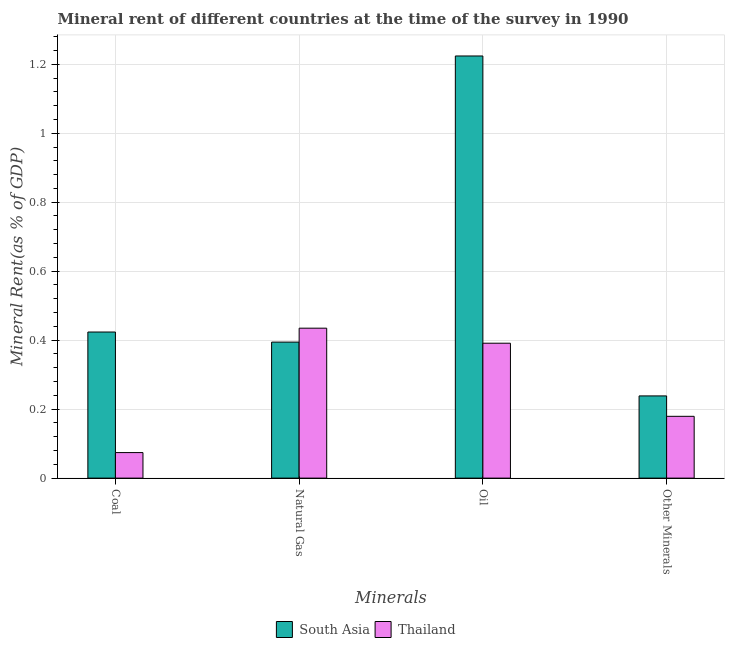How many different coloured bars are there?
Provide a short and direct response. 2. How many groups of bars are there?
Ensure brevity in your answer.  4. Are the number of bars per tick equal to the number of legend labels?
Keep it short and to the point. Yes. How many bars are there on the 1st tick from the left?
Offer a very short reply. 2. What is the label of the 1st group of bars from the left?
Keep it short and to the point. Coal. What is the  rent of other minerals in Thailand?
Offer a very short reply. 0.18. Across all countries, what is the maximum coal rent?
Make the answer very short. 0.42. Across all countries, what is the minimum oil rent?
Your response must be concise. 0.39. In which country was the natural gas rent minimum?
Provide a short and direct response. South Asia. What is the total natural gas rent in the graph?
Provide a short and direct response. 0.83. What is the difference between the coal rent in South Asia and that in Thailand?
Your response must be concise. 0.35. What is the difference between the  rent of other minerals in South Asia and the oil rent in Thailand?
Your answer should be very brief. -0.15. What is the average coal rent per country?
Offer a very short reply. 0.25. What is the difference between the  rent of other minerals and oil rent in Thailand?
Your response must be concise. -0.21. In how many countries, is the oil rent greater than 0.6400000000000001 %?
Provide a succinct answer. 1. What is the ratio of the oil rent in South Asia to that in Thailand?
Your answer should be very brief. 3.13. Is the difference between the coal rent in Thailand and South Asia greater than the difference between the  rent of other minerals in Thailand and South Asia?
Keep it short and to the point. No. What is the difference between the highest and the second highest  rent of other minerals?
Keep it short and to the point. 0.06. What is the difference between the highest and the lowest coal rent?
Provide a succinct answer. 0.35. Is the sum of the  rent of other minerals in Thailand and South Asia greater than the maximum coal rent across all countries?
Give a very brief answer. No. Is it the case that in every country, the sum of the coal rent and oil rent is greater than the sum of  rent of other minerals and natural gas rent?
Provide a short and direct response. Yes. What does the 1st bar from the left in Natural Gas represents?
Ensure brevity in your answer.  South Asia. What does the 1st bar from the right in Other Minerals represents?
Offer a terse response. Thailand. How many countries are there in the graph?
Give a very brief answer. 2. Are the values on the major ticks of Y-axis written in scientific E-notation?
Give a very brief answer. No. Does the graph contain any zero values?
Offer a terse response. No. Does the graph contain grids?
Keep it short and to the point. Yes. Where does the legend appear in the graph?
Ensure brevity in your answer.  Bottom center. How many legend labels are there?
Offer a very short reply. 2. How are the legend labels stacked?
Give a very brief answer. Horizontal. What is the title of the graph?
Your answer should be compact. Mineral rent of different countries at the time of the survey in 1990. Does "High income: nonOECD" appear as one of the legend labels in the graph?
Provide a succinct answer. No. What is the label or title of the X-axis?
Make the answer very short. Minerals. What is the label or title of the Y-axis?
Your response must be concise. Mineral Rent(as % of GDP). What is the Mineral Rent(as % of GDP) in South Asia in Coal?
Your answer should be compact. 0.42. What is the Mineral Rent(as % of GDP) in Thailand in Coal?
Your answer should be very brief. 0.07. What is the Mineral Rent(as % of GDP) in South Asia in Natural Gas?
Your response must be concise. 0.39. What is the Mineral Rent(as % of GDP) in Thailand in Natural Gas?
Your response must be concise. 0.43. What is the Mineral Rent(as % of GDP) in South Asia in Oil?
Keep it short and to the point. 1.22. What is the Mineral Rent(as % of GDP) of Thailand in Oil?
Ensure brevity in your answer.  0.39. What is the Mineral Rent(as % of GDP) of South Asia in Other Minerals?
Keep it short and to the point. 0.24. What is the Mineral Rent(as % of GDP) of Thailand in Other Minerals?
Provide a short and direct response. 0.18. Across all Minerals, what is the maximum Mineral Rent(as % of GDP) in South Asia?
Keep it short and to the point. 1.22. Across all Minerals, what is the maximum Mineral Rent(as % of GDP) of Thailand?
Your response must be concise. 0.43. Across all Minerals, what is the minimum Mineral Rent(as % of GDP) in South Asia?
Keep it short and to the point. 0.24. Across all Minerals, what is the minimum Mineral Rent(as % of GDP) of Thailand?
Provide a short and direct response. 0.07. What is the total Mineral Rent(as % of GDP) in South Asia in the graph?
Provide a short and direct response. 2.28. What is the total Mineral Rent(as % of GDP) of Thailand in the graph?
Offer a very short reply. 1.08. What is the difference between the Mineral Rent(as % of GDP) in South Asia in Coal and that in Natural Gas?
Provide a succinct answer. 0.03. What is the difference between the Mineral Rent(as % of GDP) in Thailand in Coal and that in Natural Gas?
Offer a terse response. -0.36. What is the difference between the Mineral Rent(as % of GDP) of South Asia in Coal and that in Oil?
Keep it short and to the point. -0.8. What is the difference between the Mineral Rent(as % of GDP) in Thailand in Coal and that in Oil?
Provide a succinct answer. -0.32. What is the difference between the Mineral Rent(as % of GDP) of South Asia in Coal and that in Other Minerals?
Give a very brief answer. 0.19. What is the difference between the Mineral Rent(as % of GDP) in Thailand in Coal and that in Other Minerals?
Your answer should be compact. -0.11. What is the difference between the Mineral Rent(as % of GDP) in South Asia in Natural Gas and that in Oil?
Your response must be concise. -0.83. What is the difference between the Mineral Rent(as % of GDP) in Thailand in Natural Gas and that in Oil?
Your response must be concise. 0.04. What is the difference between the Mineral Rent(as % of GDP) in South Asia in Natural Gas and that in Other Minerals?
Ensure brevity in your answer.  0.16. What is the difference between the Mineral Rent(as % of GDP) of Thailand in Natural Gas and that in Other Minerals?
Make the answer very short. 0.26. What is the difference between the Mineral Rent(as % of GDP) of South Asia in Oil and that in Other Minerals?
Keep it short and to the point. 0.99. What is the difference between the Mineral Rent(as % of GDP) in Thailand in Oil and that in Other Minerals?
Provide a short and direct response. 0.21. What is the difference between the Mineral Rent(as % of GDP) of South Asia in Coal and the Mineral Rent(as % of GDP) of Thailand in Natural Gas?
Your response must be concise. -0.01. What is the difference between the Mineral Rent(as % of GDP) of South Asia in Coal and the Mineral Rent(as % of GDP) of Thailand in Oil?
Your answer should be compact. 0.03. What is the difference between the Mineral Rent(as % of GDP) of South Asia in Coal and the Mineral Rent(as % of GDP) of Thailand in Other Minerals?
Ensure brevity in your answer.  0.24. What is the difference between the Mineral Rent(as % of GDP) in South Asia in Natural Gas and the Mineral Rent(as % of GDP) in Thailand in Oil?
Provide a short and direct response. 0. What is the difference between the Mineral Rent(as % of GDP) in South Asia in Natural Gas and the Mineral Rent(as % of GDP) in Thailand in Other Minerals?
Ensure brevity in your answer.  0.22. What is the difference between the Mineral Rent(as % of GDP) of South Asia in Oil and the Mineral Rent(as % of GDP) of Thailand in Other Minerals?
Give a very brief answer. 1.04. What is the average Mineral Rent(as % of GDP) in South Asia per Minerals?
Give a very brief answer. 0.57. What is the average Mineral Rent(as % of GDP) of Thailand per Minerals?
Your answer should be compact. 0.27. What is the difference between the Mineral Rent(as % of GDP) in South Asia and Mineral Rent(as % of GDP) in Thailand in Coal?
Offer a very short reply. 0.35. What is the difference between the Mineral Rent(as % of GDP) in South Asia and Mineral Rent(as % of GDP) in Thailand in Natural Gas?
Your response must be concise. -0.04. What is the difference between the Mineral Rent(as % of GDP) in South Asia and Mineral Rent(as % of GDP) in Thailand in Oil?
Provide a succinct answer. 0.83. What is the difference between the Mineral Rent(as % of GDP) in South Asia and Mineral Rent(as % of GDP) in Thailand in Other Minerals?
Offer a terse response. 0.06. What is the ratio of the Mineral Rent(as % of GDP) of South Asia in Coal to that in Natural Gas?
Provide a succinct answer. 1.07. What is the ratio of the Mineral Rent(as % of GDP) in Thailand in Coal to that in Natural Gas?
Offer a very short reply. 0.17. What is the ratio of the Mineral Rent(as % of GDP) of South Asia in Coal to that in Oil?
Ensure brevity in your answer.  0.35. What is the ratio of the Mineral Rent(as % of GDP) of Thailand in Coal to that in Oil?
Provide a succinct answer. 0.19. What is the ratio of the Mineral Rent(as % of GDP) of South Asia in Coal to that in Other Minerals?
Provide a short and direct response. 1.78. What is the ratio of the Mineral Rent(as % of GDP) of Thailand in Coal to that in Other Minerals?
Your response must be concise. 0.41. What is the ratio of the Mineral Rent(as % of GDP) of South Asia in Natural Gas to that in Oil?
Your answer should be very brief. 0.32. What is the ratio of the Mineral Rent(as % of GDP) of Thailand in Natural Gas to that in Oil?
Your answer should be very brief. 1.11. What is the ratio of the Mineral Rent(as % of GDP) in South Asia in Natural Gas to that in Other Minerals?
Ensure brevity in your answer.  1.65. What is the ratio of the Mineral Rent(as % of GDP) of Thailand in Natural Gas to that in Other Minerals?
Make the answer very short. 2.43. What is the ratio of the Mineral Rent(as % of GDP) in South Asia in Oil to that in Other Minerals?
Make the answer very short. 5.13. What is the ratio of the Mineral Rent(as % of GDP) of Thailand in Oil to that in Other Minerals?
Offer a terse response. 2.18. What is the difference between the highest and the second highest Mineral Rent(as % of GDP) of South Asia?
Offer a very short reply. 0.8. What is the difference between the highest and the second highest Mineral Rent(as % of GDP) of Thailand?
Offer a terse response. 0.04. What is the difference between the highest and the lowest Mineral Rent(as % of GDP) in South Asia?
Provide a succinct answer. 0.99. What is the difference between the highest and the lowest Mineral Rent(as % of GDP) in Thailand?
Your response must be concise. 0.36. 